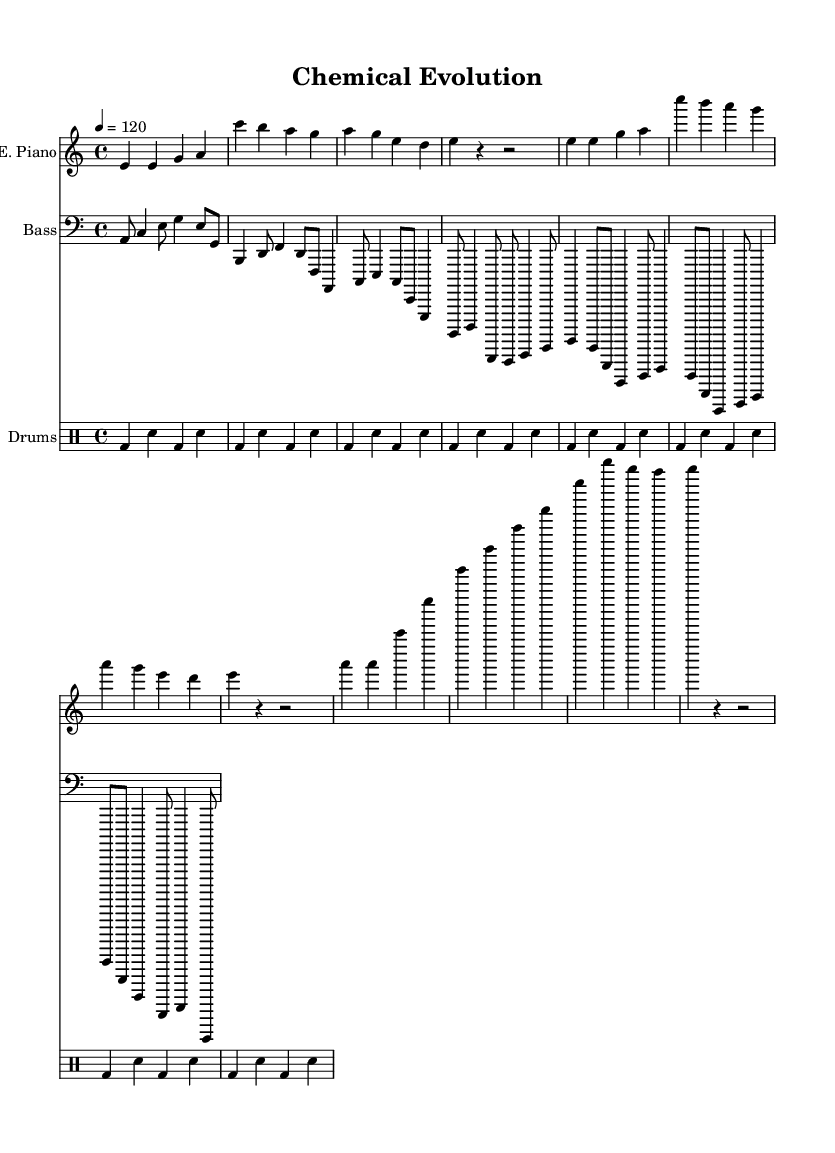What is the key signature of this music? The key signature is A minor, which has no sharps or flats. A minor is the relative minor of C major.
Answer: A minor What is the time signature of this music? The time signature is 4/4, indicating four beats per measure, with a quarter note receiving one beat. This is a common time signature used in disco music.
Answer: 4/4 What is the tempo marking for this piece? The tempo marking indicates a speed of 120 beats per minute, meaning the quarter notes are played at a moderate pace, typical for disco tunes.
Answer: 120 How many measures are shown in the electric piano part? By counting the groupings of notes, it is observed that there are a total of 8 measures in the electric piano part as indicated by the repeated sections.
Answer: 8 What is the primary rhythm used in the drums part? The drums part features a consistent bass-drum and snare pattern repeated throughout, which is characteristic of disco music, providing a steady danceable groove.
Answer: Bass-drum and snare What is the highest note played in the electric piano part? The highest note in the electric piano part is E in the second octave (E'), as indicated by the notation in the sheet music, making it the peak frequency of the melody.
Answer: E prime What is the instrument used for the bass part? The instrument used for the bass part is the bass guitar, which is typically employed in disco music to provide a rhythmic and harmonic foundation.
Answer: Bass guitar 